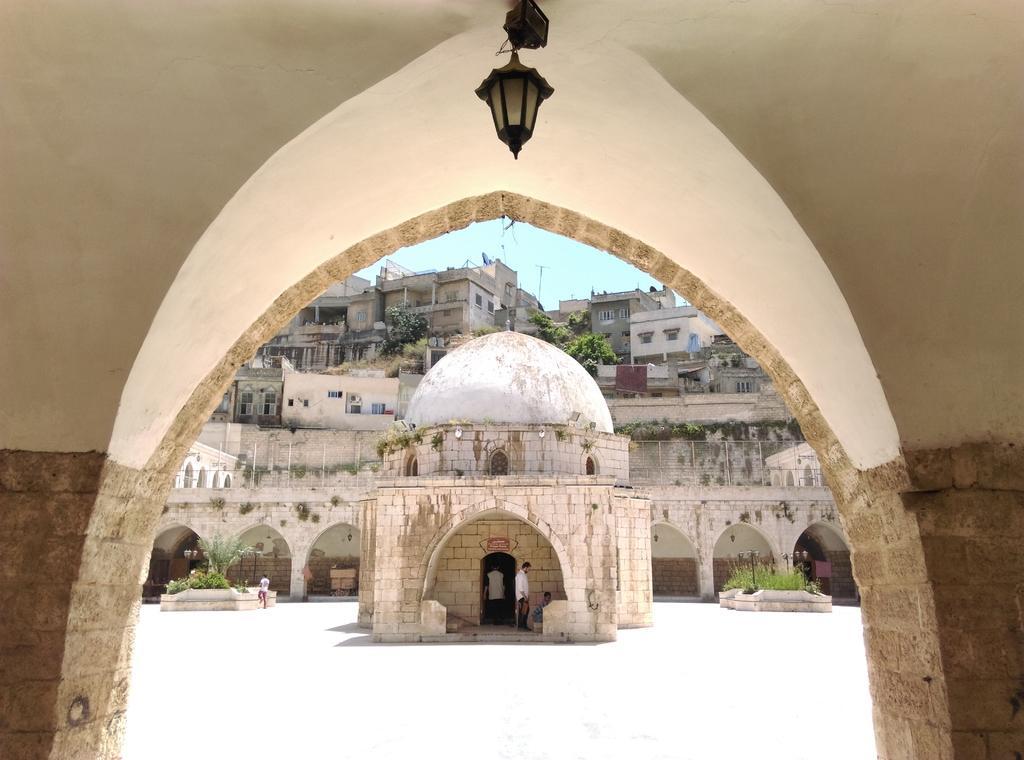In one or two sentences, can you explain what this image depicts? In front of the image there is a wall. There is a light. In the center of the image there are people standing under the building. There are plants. There are light poles. In the background of the image there are buildings, trees and sky. 